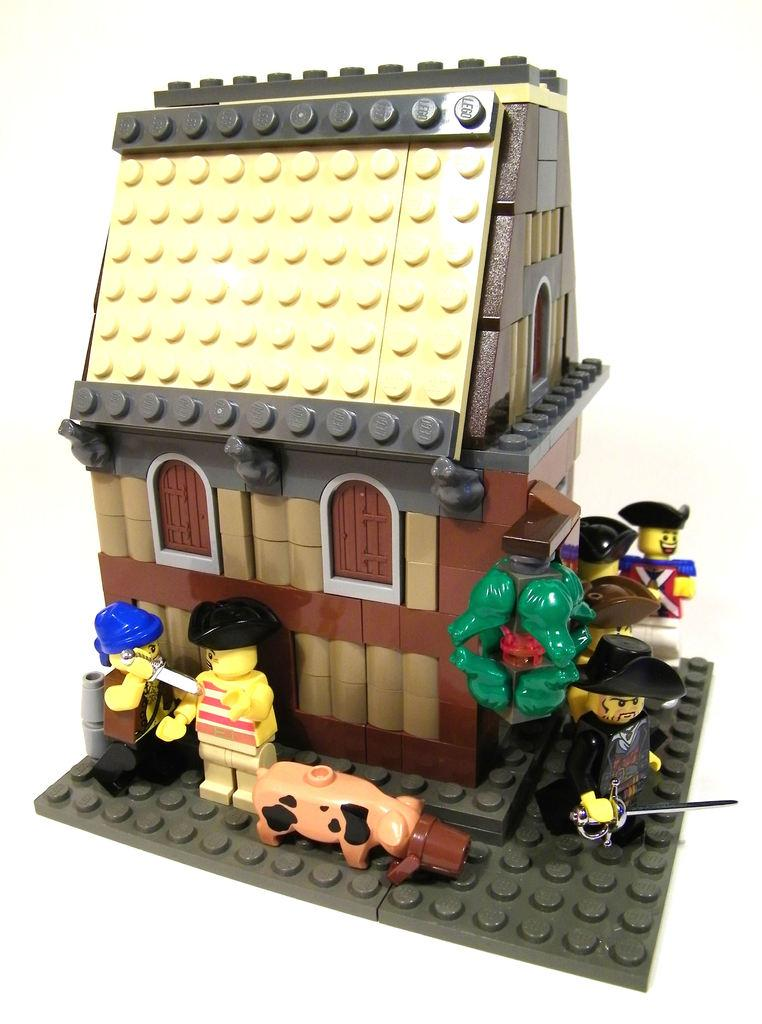What type of structure is depicted in the image? There is a toy house in the image. How was the toy house constructed? The toy house is built with building blocks. What type of corn is growing in the image? There is no corn present in the image; it features a toy house built with building blocks. What month is depicted on the calendar in the image? There is no calendar present in the image. 